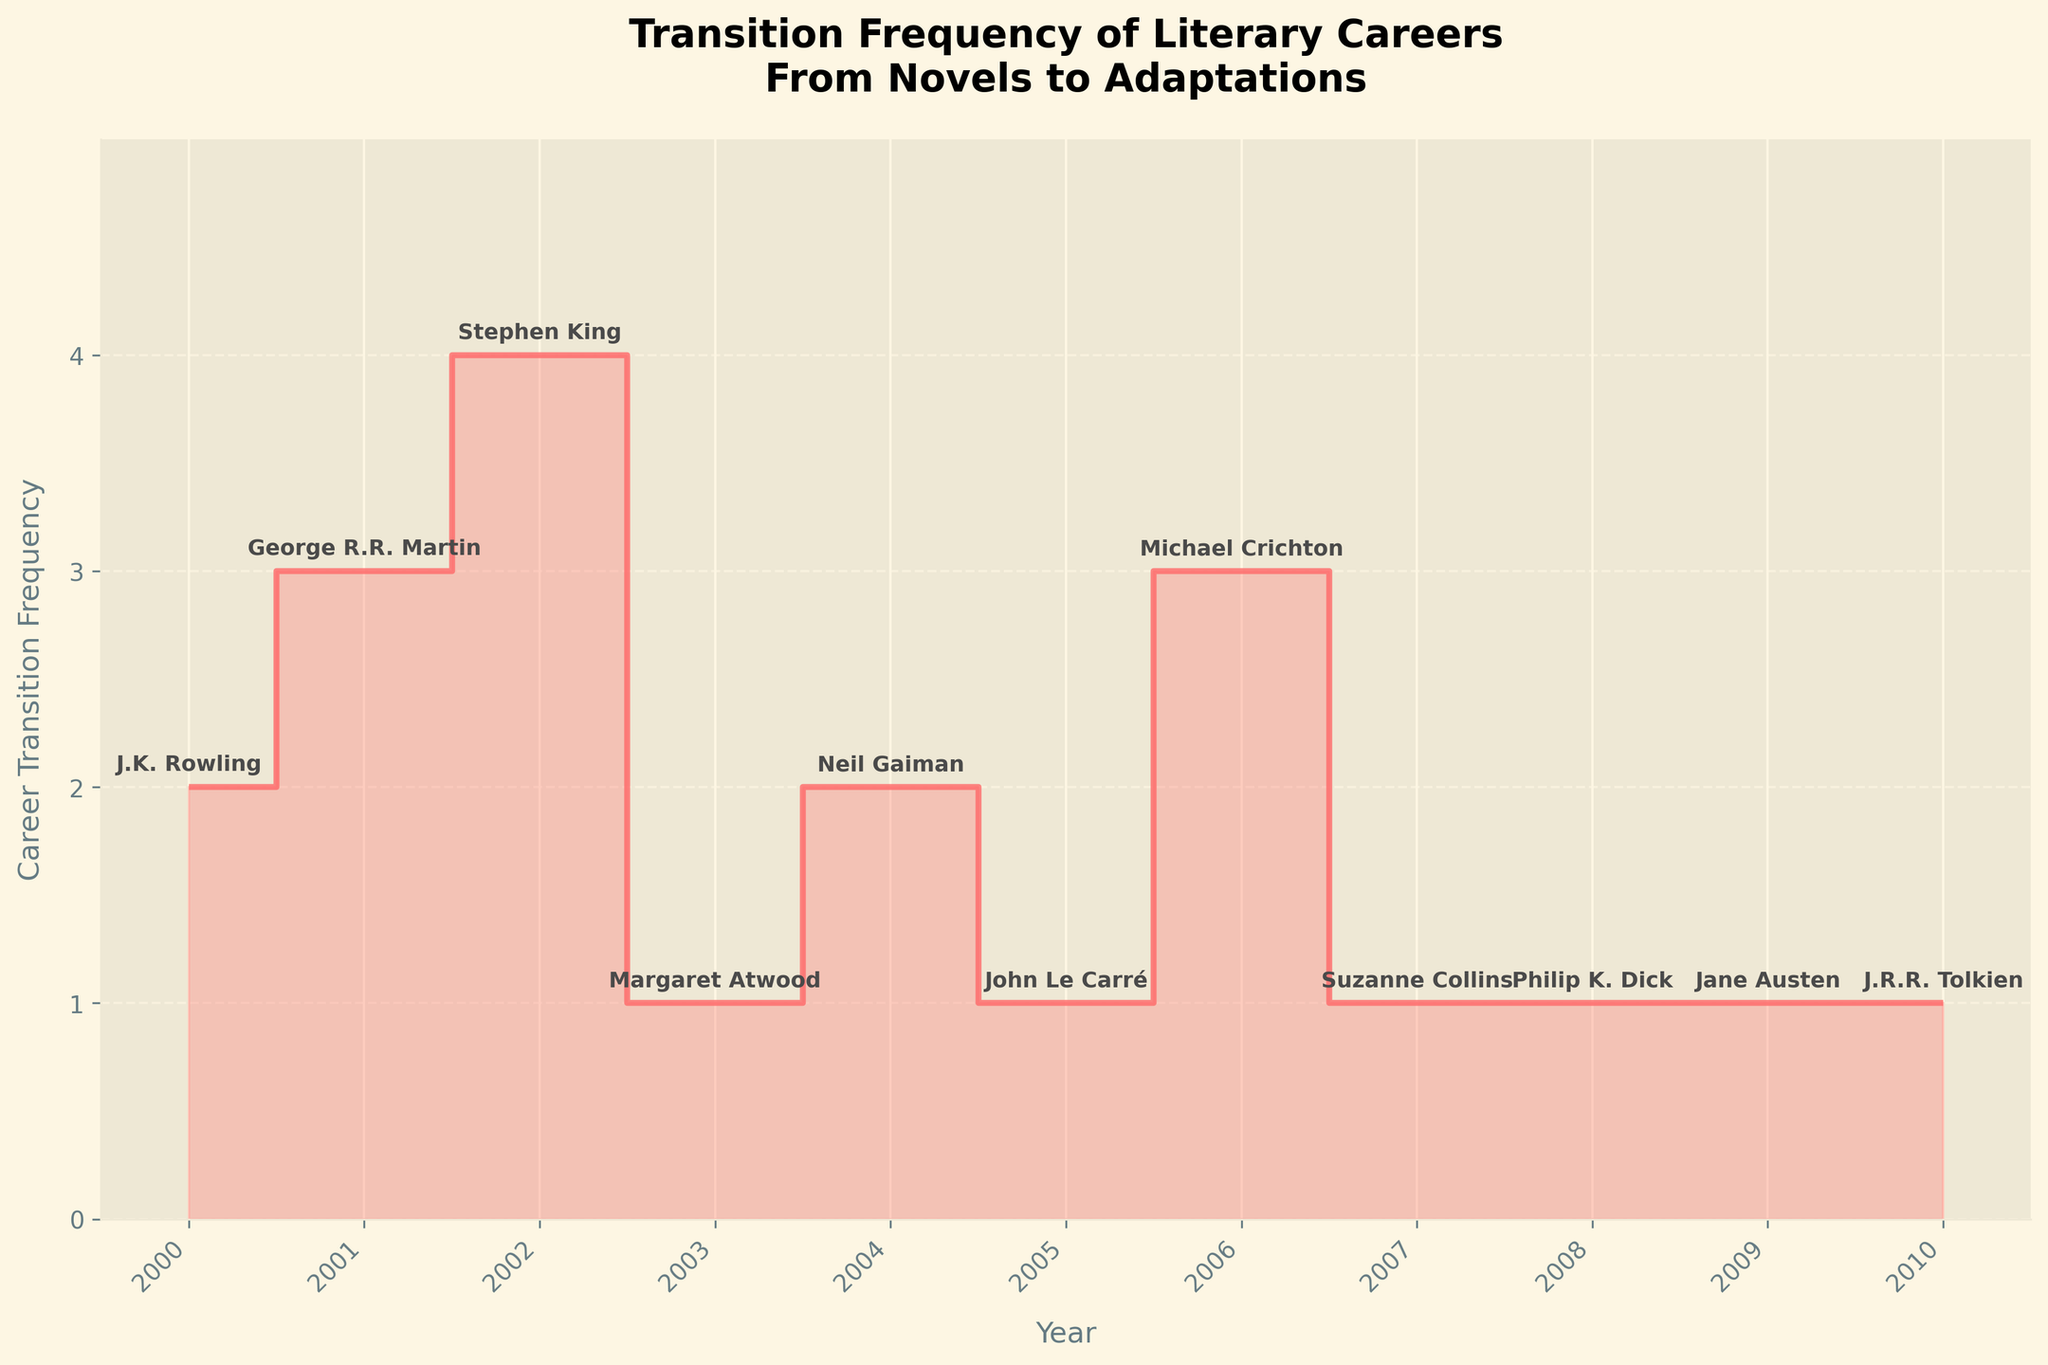What's the title of the figure? The title is located at the top of the figure, providing an overview of what the plot represents. It is "Transition Frequency of Literary Careers From Novels to Adaptations".
Answer: Transition Frequency of Literary Careers From Novels to Adaptations What years are covered in the plot? The x-axis labels in the figure indicate the range of years covered. They span from "2000" to "2010".
Answer: 2000 to 2010 Which author had the highest career transition frequency? By observing the plot, the highest step on the y-axis shows the frequency and the corresponding year label can be traced to identify the author. Stephen King had the highest frequency with a value of 4 in 2002.
Answer: Stephen King How many authors transitioned their careers exactly once? Count the number of steps on the plot with a height of 1. There are six authors (Margaret Atwood, John Le Carré, Suzanne Collins, Philip K. Dick, Jane Austen, J.R.R. Tolkien) who transitioned exactly once.
Answer: 6 What was the career transition frequency for George R.R. Martin? Locate George R.R. Martin's name on the plot, and observe the corresponding career transition frequency on the y-axis, which is 3 in 2001.
Answer: 3 Which year had the highest total career transition frequency? Add the career transition frequencies for each year and compare. 2002 has the highest total frequency with a value of 4.
Answer: 2002 What's the difference in career transition frequency between Michael Crichton and J.K. Rowling? Subtract the frequency value of J.K. Rowling (2) from Michael Crichton (3). The difference is 1.
Answer: 1 Did any author have a career transition frequency of 5? Check the y-axis for a frequency value of 5 and see if any author corresponds to that value. There are no authors with a frequency as high as 5.
Answer: No Between years 2004 and 2006, did the career transition frequency increase, decrease, or stay the same? Compare the y-values for 2004 (Neil Gaiman, 2) and 2006 (Michael Crichton, 3). The frequency increased.
Answer: Increase How many authors had a career transition frequency greater than 2? Identify and count the authors whose transition frequency values on the plot are greater than 2. There are three authors: George R.R. Martin (3), Stephen King (4), and Michael Crichton (3).
Answer: 3 